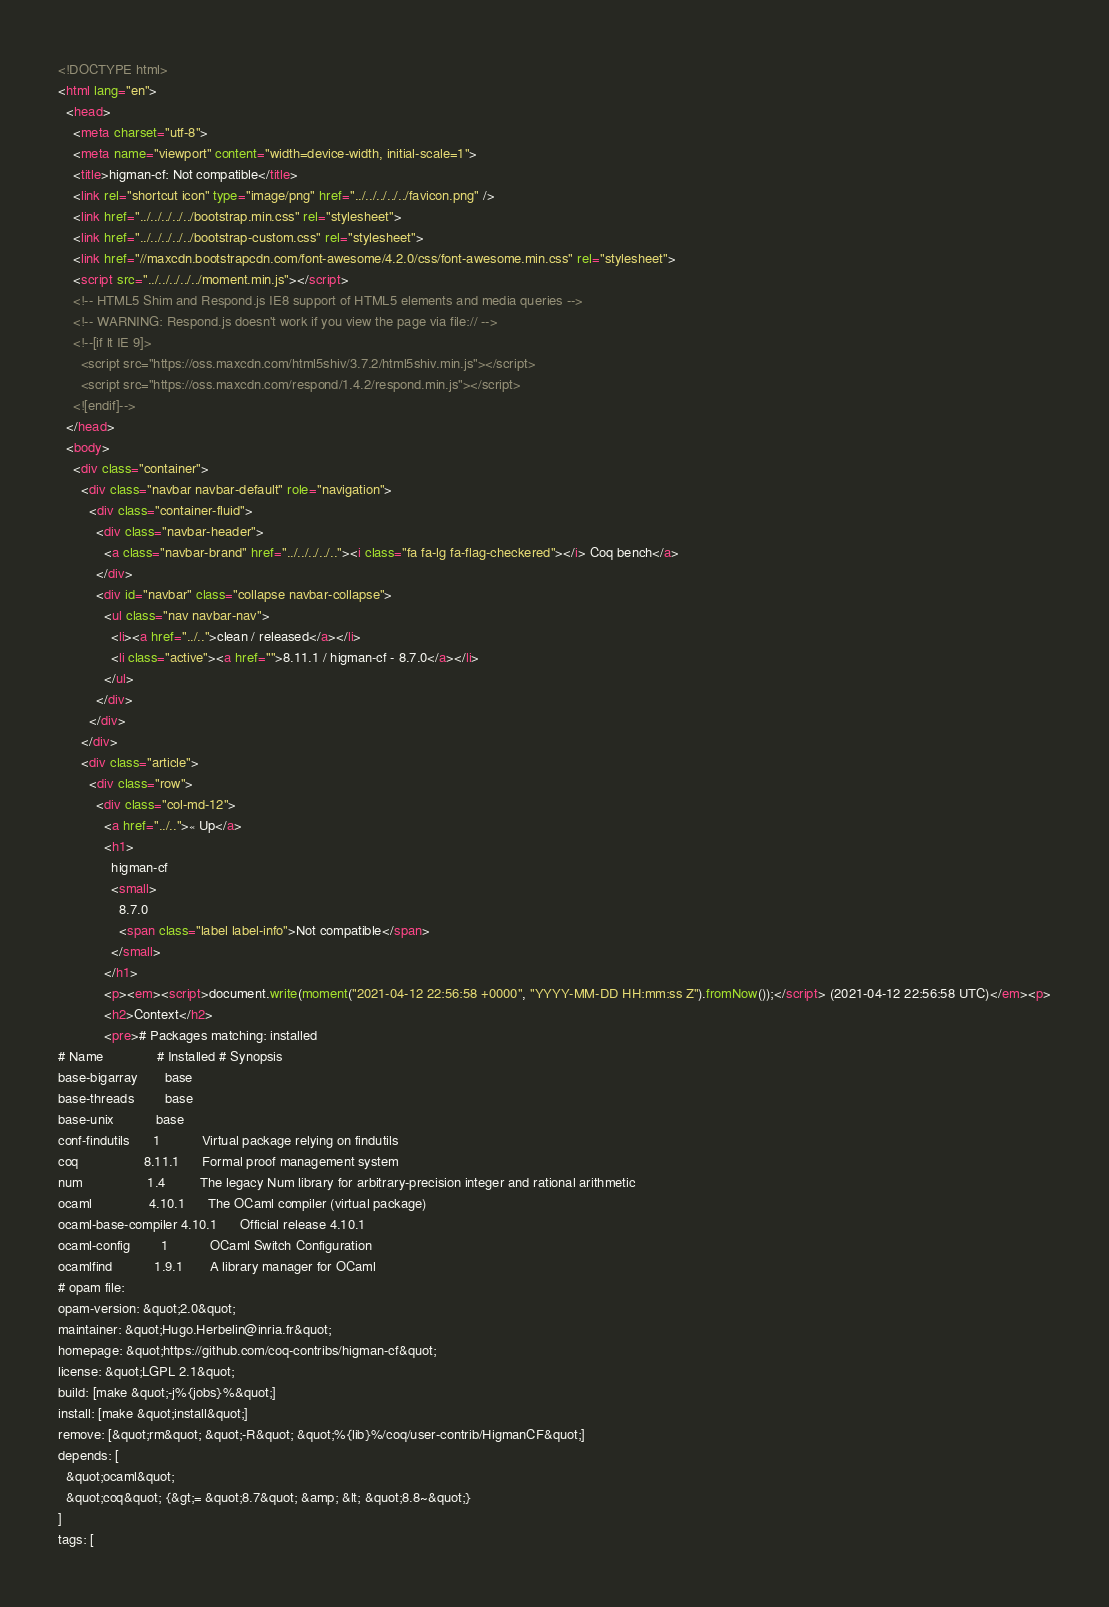Convert code to text. <code><loc_0><loc_0><loc_500><loc_500><_HTML_><!DOCTYPE html>
<html lang="en">
  <head>
    <meta charset="utf-8">
    <meta name="viewport" content="width=device-width, initial-scale=1">
    <title>higman-cf: Not compatible</title>
    <link rel="shortcut icon" type="image/png" href="../../../../../favicon.png" />
    <link href="../../../../../bootstrap.min.css" rel="stylesheet">
    <link href="../../../../../bootstrap-custom.css" rel="stylesheet">
    <link href="//maxcdn.bootstrapcdn.com/font-awesome/4.2.0/css/font-awesome.min.css" rel="stylesheet">
    <script src="../../../../../moment.min.js"></script>
    <!-- HTML5 Shim and Respond.js IE8 support of HTML5 elements and media queries -->
    <!-- WARNING: Respond.js doesn't work if you view the page via file:// -->
    <!--[if lt IE 9]>
      <script src="https://oss.maxcdn.com/html5shiv/3.7.2/html5shiv.min.js"></script>
      <script src="https://oss.maxcdn.com/respond/1.4.2/respond.min.js"></script>
    <![endif]-->
  </head>
  <body>
    <div class="container">
      <div class="navbar navbar-default" role="navigation">
        <div class="container-fluid">
          <div class="navbar-header">
            <a class="navbar-brand" href="../../../../.."><i class="fa fa-lg fa-flag-checkered"></i> Coq bench</a>
          </div>
          <div id="navbar" class="collapse navbar-collapse">
            <ul class="nav navbar-nav">
              <li><a href="../..">clean / released</a></li>
              <li class="active"><a href="">8.11.1 / higman-cf - 8.7.0</a></li>
            </ul>
          </div>
        </div>
      </div>
      <div class="article">
        <div class="row">
          <div class="col-md-12">
            <a href="../..">« Up</a>
            <h1>
              higman-cf
              <small>
                8.7.0
                <span class="label label-info">Not compatible</span>
              </small>
            </h1>
            <p><em><script>document.write(moment("2021-04-12 22:56:58 +0000", "YYYY-MM-DD HH:mm:ss Z").fromNow());</script> (2021-04-12 22:56:58 UTC)</em><p>
            <h2>Context</h2>
            <pre># Packages matching: installed
# Name              # Installed # Synopsis
base-bigarray       base
base-threads        base
base-unix           base
conf-findutils      1           Virtual package relying on findutils
coq                 8.11.1      Formal proof management system
num                 1.4         The legacy Num library for arbitrary-precision integer and rational arithmetic
ocaml               4.10.1      The OCaml compiler (virtual package)
ocaml-base-compiler 4.10.1      Official release 4.10.1
ocaml-config        1           OCaml Switch Configuration
ocamlfind           1.9.1       A library manager for OCaml
# opam file:
opam-version: &quot;2.0&quot;
maintainer: &quot;Hugo.Herbelin@inria.fr&quot;
homepage: &quot;https://github.com/coq-contribs/higman-cf&quot;
license: &quot;LGPL 2.1&quot;
build: [make &quot;-j%{jobs}%&quot;]
install: [make &quot;install&quot;]
remove: [&quot;rm&quot; &quot;-R&quot; &quot;%{lib}%/coq/user-contrib/HigmanCF&quot;]
depends: [
  &quot;ocaml&quot;
  &quot;coq&quot; {&gt;= &quot;8.7&quot; &amp; &lt; &quot;8.8~&quot;}
]
tags: [</code> 